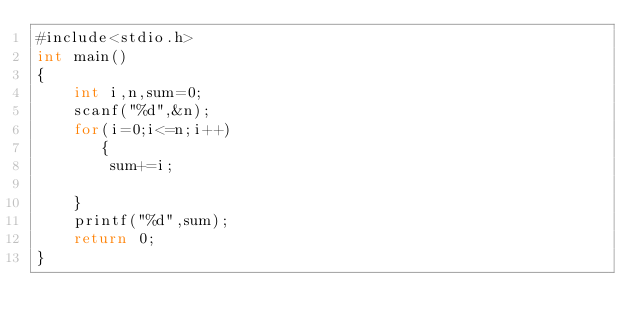Convert code to text. <code><loc_0><loc_0><loc_500><loc_500><_C#_>#include<stdio.h>
int main()
{
    int i,n,sum=0;
    scanf("%d",&n);
    for(i=0;i<=n;i++)
       {
        sum+=i;

    }
    printf("%d",sum);
    return 0;
}
</code> 